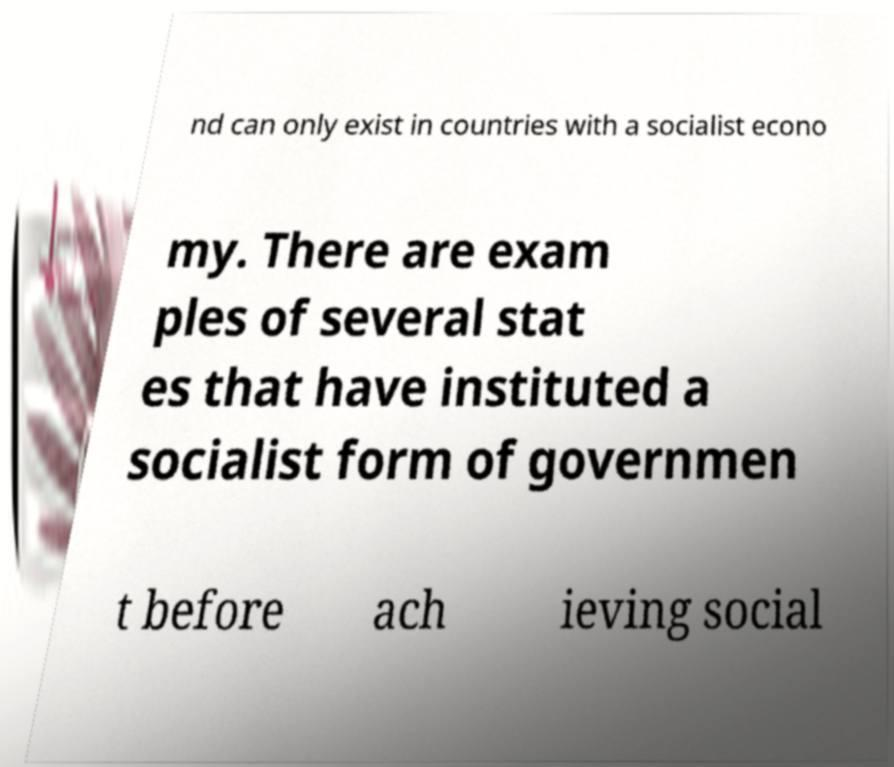For documentation purposes, I need the text within this image transcribed. Could you provide that? nd can only exist in countries with a socialist econo my. There are exam ples of several stat es that have instituted a socialist form of governmen t before ach ieving social 